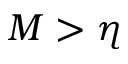Convert formula to latex. <formula><loc_0><loc_0><loc_500><loc_500>M > \eta</formula> 